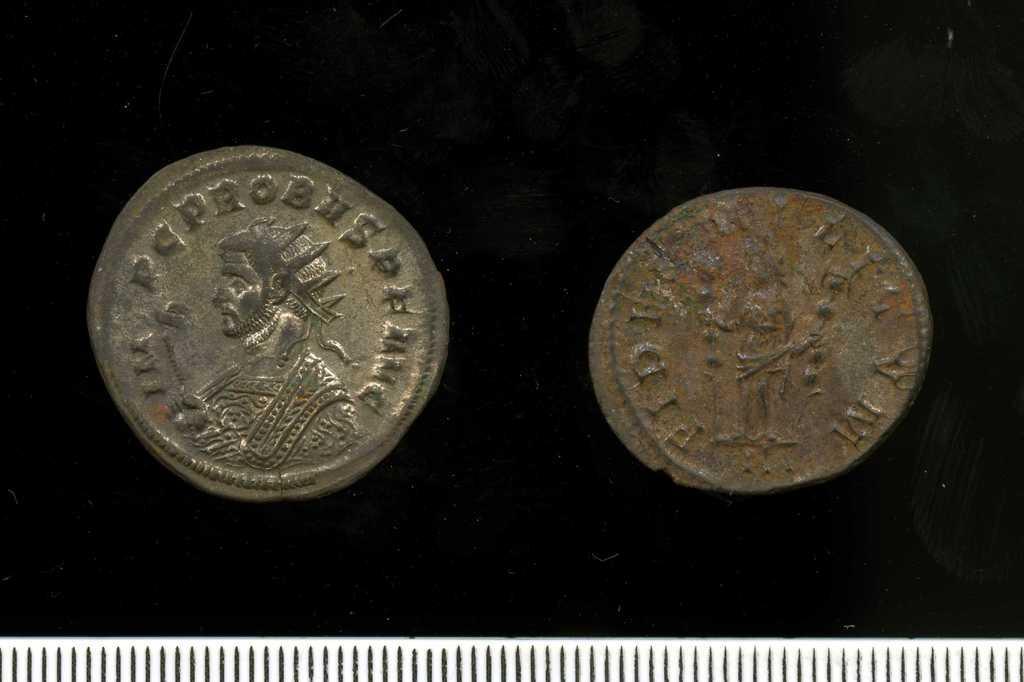Describe this image in one or two sentences. In this image, we can see two coins with some text and figures on the black cloth. At the bottom, we can see a white color object with black lines. 